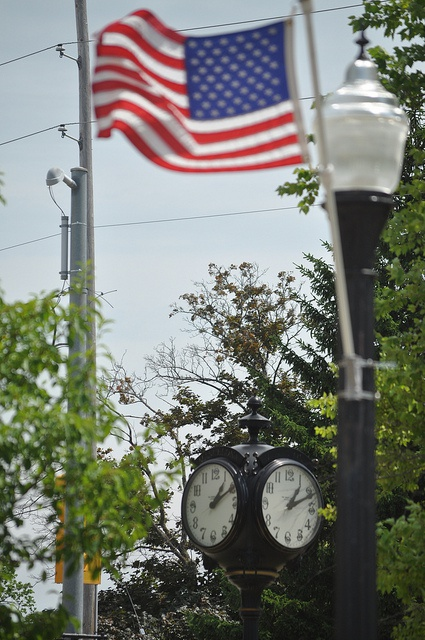Describe the objects in this image and their specific colors. I can see clock in darkgray, gray, and black tones, clock in darkgray, gray, and black tones, and traffic light in darkgray, olive, black, and darkgreen tones in this image. 